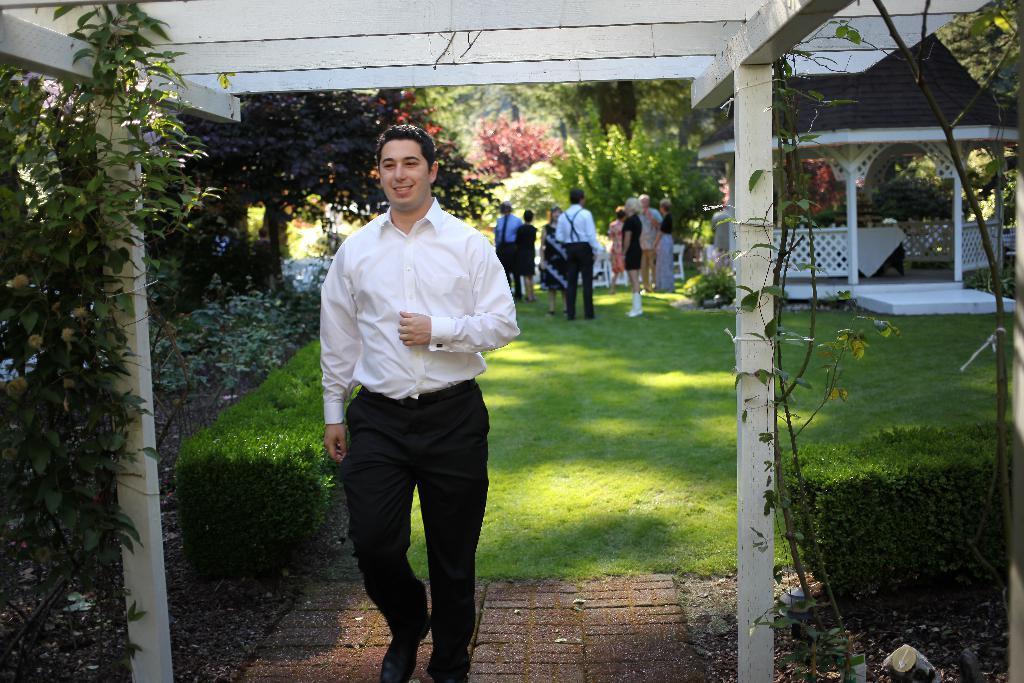Can you describe this image briefly? In the image I can see a person in white and black dress and behind there are some trees, plants, fencing under the roof and some other things around. 